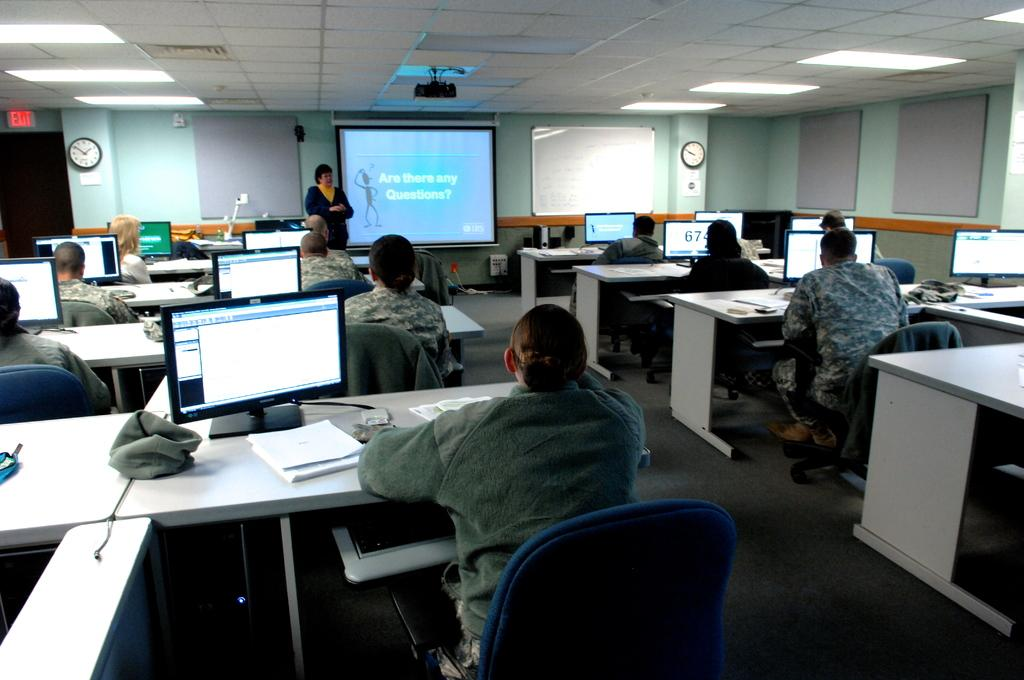<image>
Offer a succinct explanation of the picture presented. Group of people looking at a lecture on the screen that says "Are there any Questions?". 